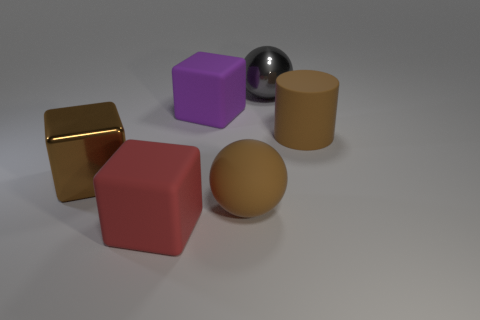Are there more gray shiny objects than large blue cylinders?
Offer a terse response. Yes. How many things are brown things that are right of the red matte cube or objects on the left side of the rubber cylinder?
Offer a terse response. 6. There is another metal thing that is the same size as the gray thing; what color is it?
Give a very brief answer. Brown. Is the gray thing made of the same material as the brown block?
Give a very brief answer. Yes. What material is the ball in front of the brown shiny thing on the left side of the purple block?
Offer a very short reply. Rubber. Are there more big rubber things that are behind the brown cube than purple rubber things?
Your answer should be very brief. Yes. What number of other things are the same size as the purple rubber block?
Keep it short and to the point. 5. Is the matte cylinder the same color as the metal cube?
Offer a terse response. Yes. There is a large thing that is in front of the ball that is in front of the object behind the purple cube; what is its color?
Provide a short and direct response. Red. How many big brown cylinders are to the right of the brown object that is in front of the brown object left of the purple matte cube?
Ensure brevity in your answer.  1. 